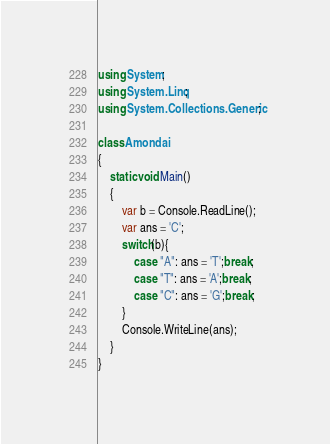<code> <loc_0><loc_0><loc_500><loc_500><_C#_>using System;
using System.Linq;
using System.Collections.Generic;

class Amondai
{
    static void Main()
    {
        var b = Console.ReadLine();
        var ans = 'C';
        switch(b){
            case "A": ans = 'T';break;
            case "T": ans = 'A';break;
            case "C": ans = 'G';break;
        }
        Console.WriteLine(ans);
    }
}</code> 